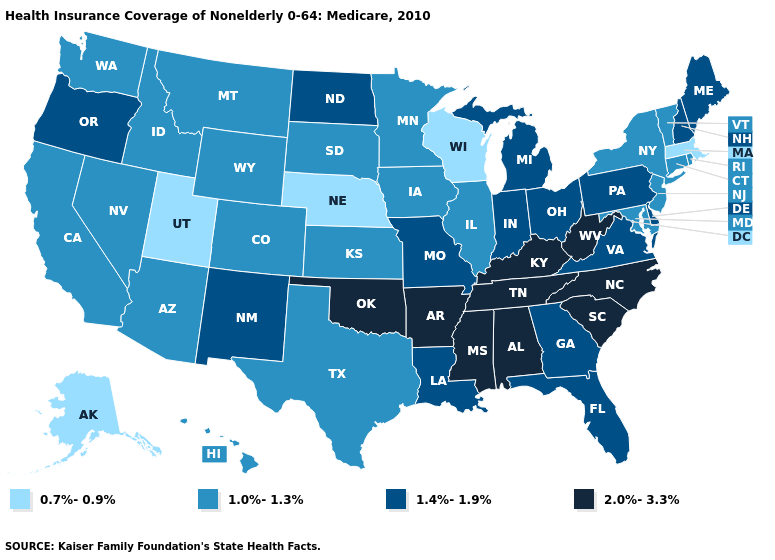Name the states that have a value in the range 2.0%-3.3%?
Quick response, please. Alabama, Arkansas, Kentucky, Mississippi, North Carolina, Oklahoma, South Carolina, Tennessee, West Virginia. What is the value of Connecticut?
Keep it brief. 1.0%-1.3%. What is the lowest value in states that border Ohio?
Be succinct. 1.4%-1.9%. What is the value of Michigan?
Concise answer only. 1.4%-1.9%. Name the states that have a value in the range 2.0%-3.3%?
Concise answer only. Alabama, Arkansas, Kentucky, Mississippi, North Carolina, Oklahoma, South Carolina, Tennessee, West Virginia. What is the value of Illinois?
Quick response, please. 1.0%-1.3%. Does North Carolina have the highest value in the USA?
Short answer required. Yes. Which states have the lowest value in the USA?
Write a very short answer. Alaska, Massachusetts, Nebraska, Utah, Wisconsin. Does the map have missing data?
Quick response, please. No. Name the states that have a value in the range 0.7%-0.9%?
Concise answer only. Alaska, Massachusetts, Nebraska, Utah, Wisconsin. Which states have the lowest value in the Northeast?
Short answer required. Massachusetts. Does Vermont have the lowest value in the USA?
Be succinct. No. Name the states that have a value in the range 0.7%-0.9%?
Concise answer only. Alaska, Massachusetts, Nebraska, Utah, Wisconsin. Among the states that border Virginia , which have the highest value?
Concise answer only. Kentucky, North Carolina, Tennessee, West Virginia. 